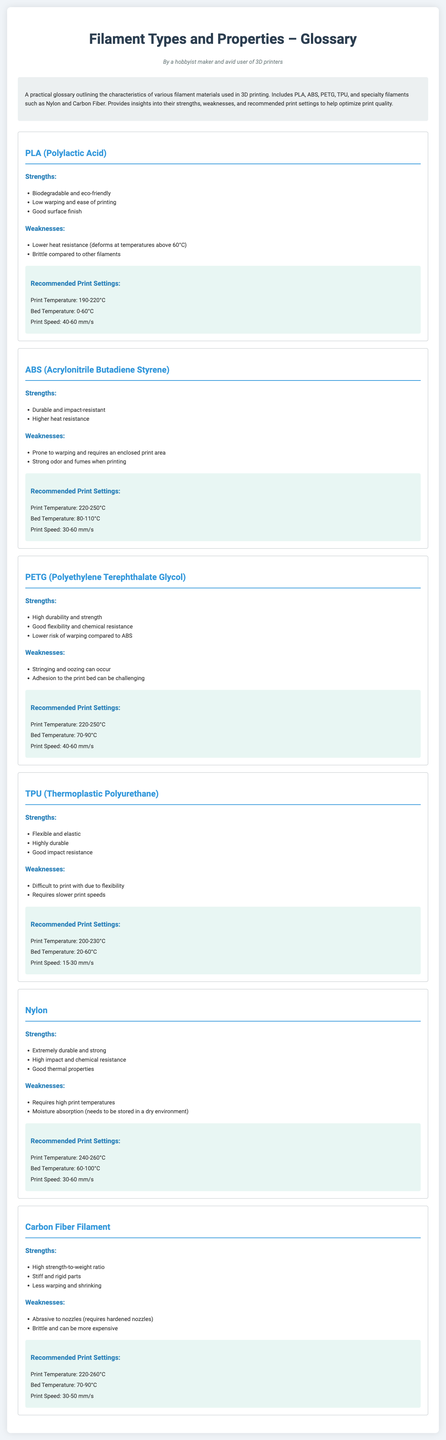What is the print temperature range for PLA? The print temperature range for PLA is specifically mentioned in the document as 190-220°C.
Answer: 190-220°C What are the strengths of ABS? The strengths of ABS include durability and impact resistance, as mentioned under the strengths section for ABS in the document.
Answer: Durable and impact-resistant What is the recommended bed temperature for PETG? The document specifies the recommended bed temperature for PETG as 70-90°C.
Answer: 70-90°C Which filament type is described as flexible and elastic? The document states that TPU is characterized as flexible and elastic in the strengths section.
Answer: TPU What is a common weakness of Nylon? The document indicates that a common weakness of Nylon is moisture absorption, requiring it to be stored in a dry environment.
Answer: Moisture absorption What filament has a high strength-to-weight ratio? The document highlights that Carbon Fiber Filament has a high strength-to-weight ratio in its strengths section.
Answer: Carbon Fiber Filament Which filament requires an enclosed print area? The document explicitly states that ABS is prone to warping and requires an enclosed print area in its weaknesses section.
Answer: ABS What is the recommended print speed range for TPU? The document lists the recommended print speed range for TPU as 15-30 mm/s.
Answer: 15-30 mm/s 